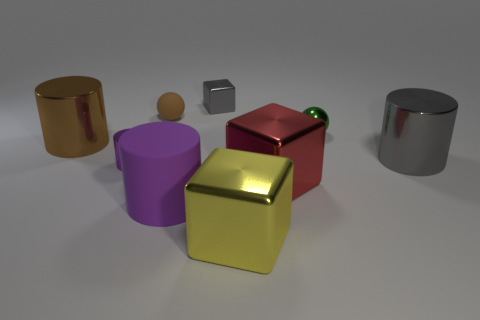Subtract all large cylinders. How many cylinders are left? 1 Subtract all yellow cubes. How many cubes are left? 2 Subtract all cylinders. How many objects are left? 5 Subtract 2 spheres. How many spheres are left? 0 Subtract all yellow cubes. Subtract all purple cylinders. How many cubes are left? 2 Subtract all green balls. How many cyan cubes are left? 0 Subtract all big gray matte objects. Subtract all small gray shiny objects. How many objects are left? 8 Add 8 big purple cylinders. How many big purple cylinders are left? 9 Add 3 small cylinders. How many small cylinders exist? 4 Subtract 0 green cylinders. How many objects are left? 9 